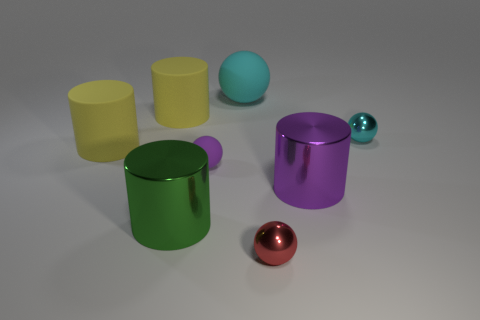Add 1 big yellow matte cylinders. How many objects exist? 9 Add 1 metal objects. How many metal objects exist? 5 Subtract 0 gray cylinders. How many objects are left? 8 Subtract all yellow matte objects. Subtract all large rubber cylinders. How many objects are left? 4 Add 3 yellow cylinders. How many yellow cylinders are left? 5 